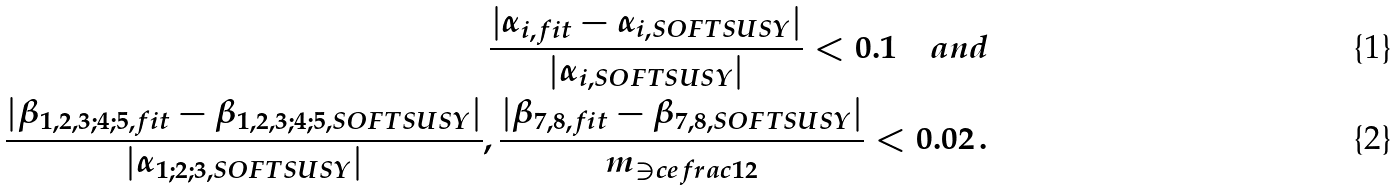Convert formula to latex. <formula><loc_0><loc_0><loc_500><loc_500>\frac { | \alpha _ { i , f i t } - \alpha _ { i , S O F T S U S Y } | } { | \alpha _ { i , S O F T S U S Y } | } < 0 . 1 \quad a n d \\ \frac { | \beta _ { 1 , 2 , 3 ; 4 ; 5 , f i t } - \beta _ { 1 , 2 , 3 ; 4 ; 5 , S O F T S U S Y } | } { | \alpha _ { 1 ; 2 ; 3 , S O F T S U S Y } | } , \frac { | \beta _ { 7 , 8 , f i t } - \beta _ { 7 , 8 , S O F T S U S Y } | } { m _ { \ni c e f r a c { 1 } { 2 } } } < 0 . 0 2 \, .</formula> 